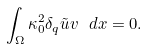<formula> <loc_0><loc_0><loc_500><loc_500>\int _ { \Omega } \kappa _ { 0 } ^ { 2 } \delta _ { q } \tilde { u } v \ d x = 0 .</formula> 